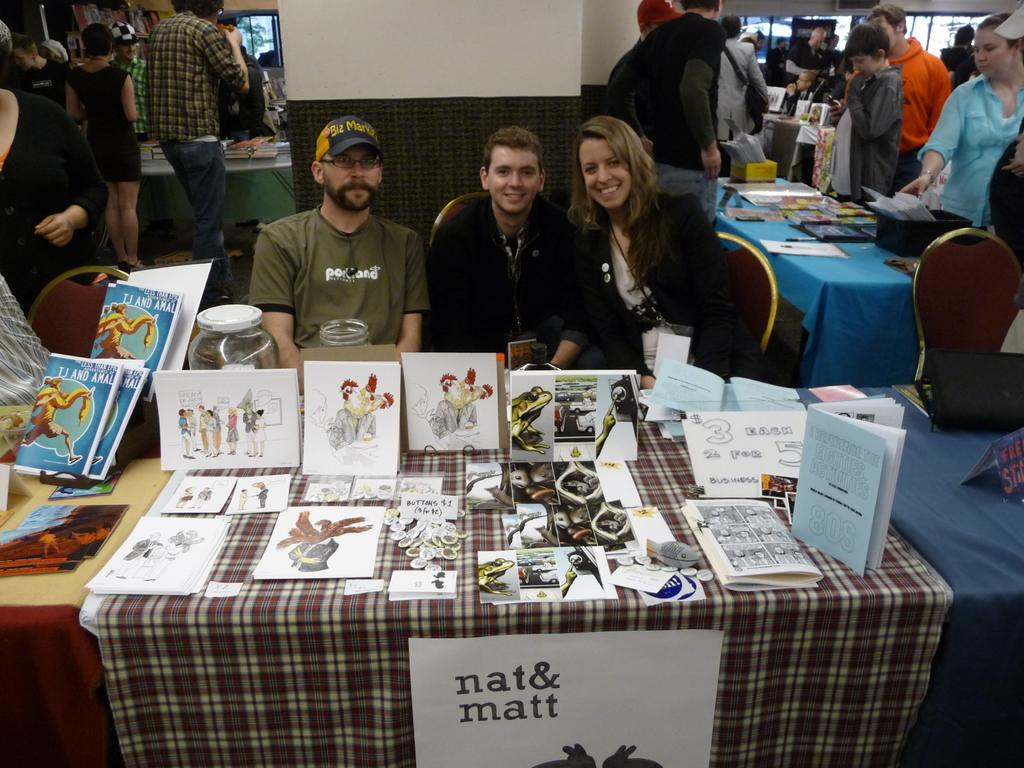How many people are sitting on the chair in the image? There are three people sitting on a chair in the image. What can be found on the table in the image? There are pictures, a book, and cloth on the table in the image. Are there any people standing in the background of the image? Yes, there are people standing in the background of the image. What type of cloud is visible in the image? There is no cloud visible in the image. What color is the hair of the person sitting on the chair? The provided facts do not mention hair color, so it cannot be determined from the image. 